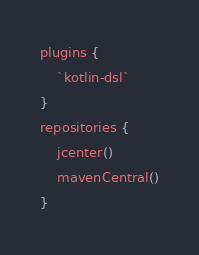<code> <loc_0><loc_0><loc_500><loc_500><_Kotlin_>plugins {
    `kotlin-dsl`
}
repositories {
    jcenter()
    mavenCentral()
}</code> 